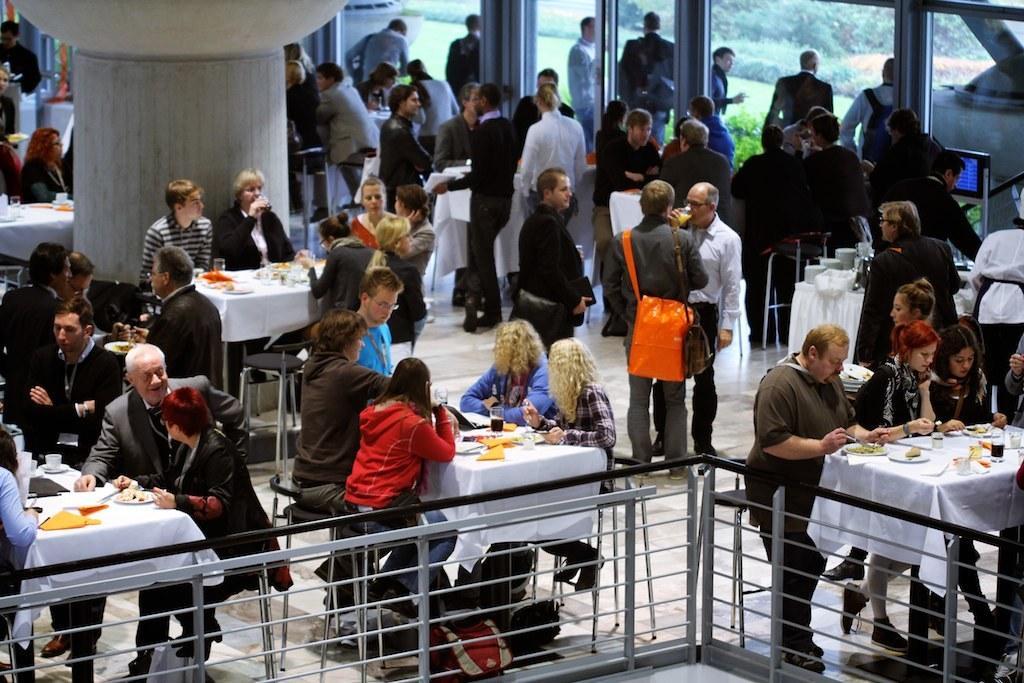In one or two sentences, can you explain what this image depicts? In this picture there are group of people on to the right there are people standing, on the left they are sitting and they have a table in front of them with some food served on it. IN the backdrop there is a pole and there is a window. 